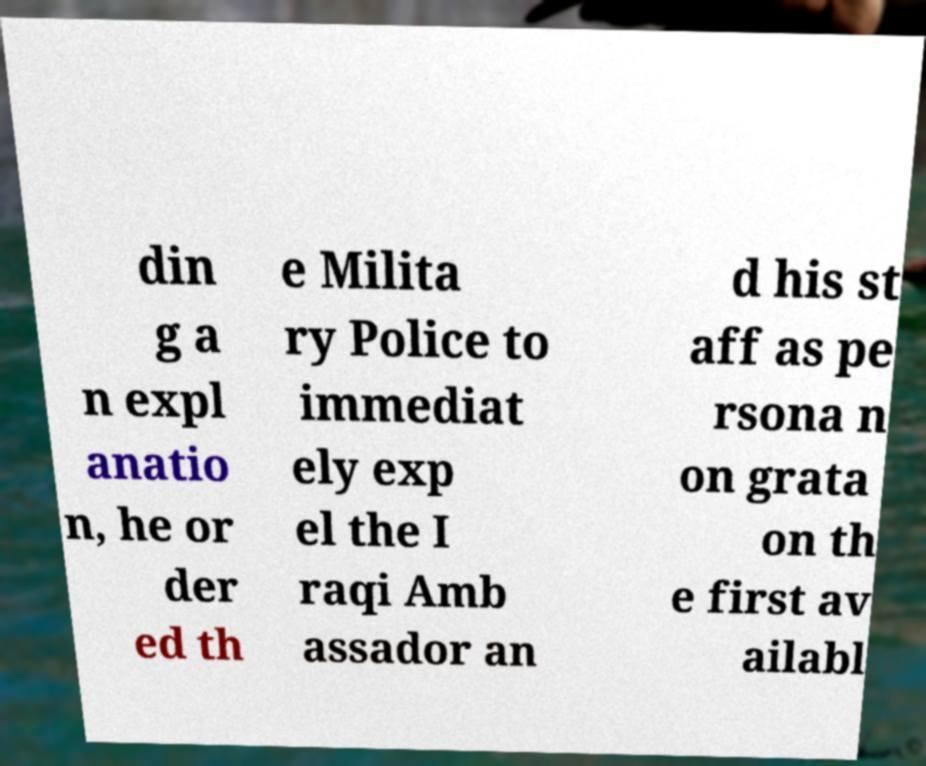Could you assist in decoding the text presented in this image and type it out clearly? din g a n expl anatio n, he or der ed th e Milita ry Police to immediat ely exp el the I raqi Amb assador an d his st aff as pe rsona n on grata on th e first av ailabl 